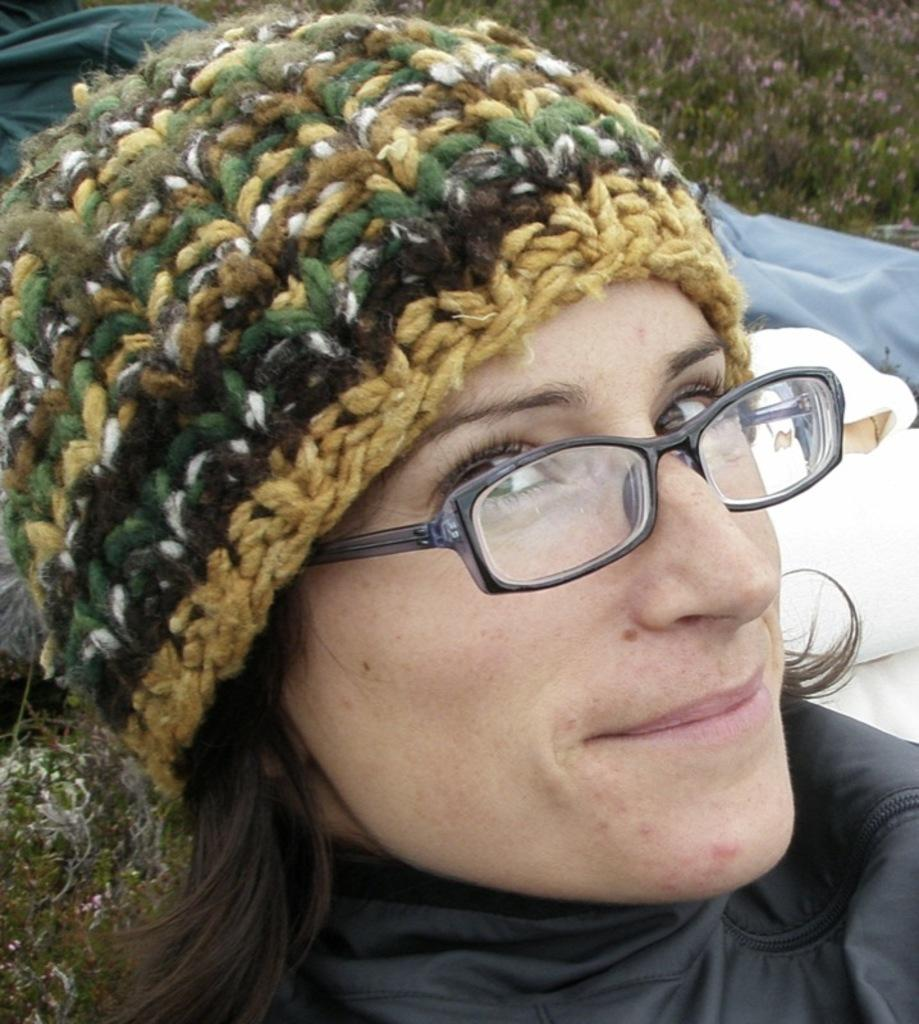What is the main subject of the image? There is a girl's face in the image. What accessories is the girl wearing? The girl is wearing spectacles and a cap. What can be seen in the background of the image? There are small plants with flowers in the background of the image. What is located at the bottom of the image? There are clothes at the bottom of the image. What is the girl's opinion on the lamp in the image? There is no lamp present in the image, so it is not possible to determine the girl's opinion on it. 